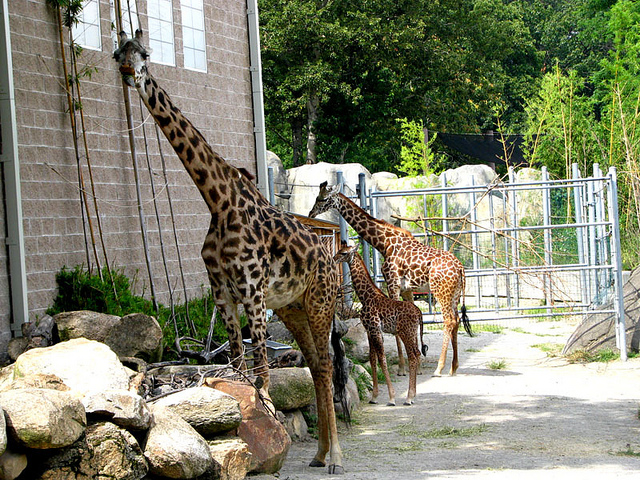<image>How many rocks are piled to the left of the larger giraffe? I don't know the exact number of rocks piled to the left of the larger giraffe. How many rocks are piled to the left of the larger giraffe? I don't know how many rocks are piled to the left of the larger giraffe. There can be different numbers of rocks, such as 8, 14, or even 20. 